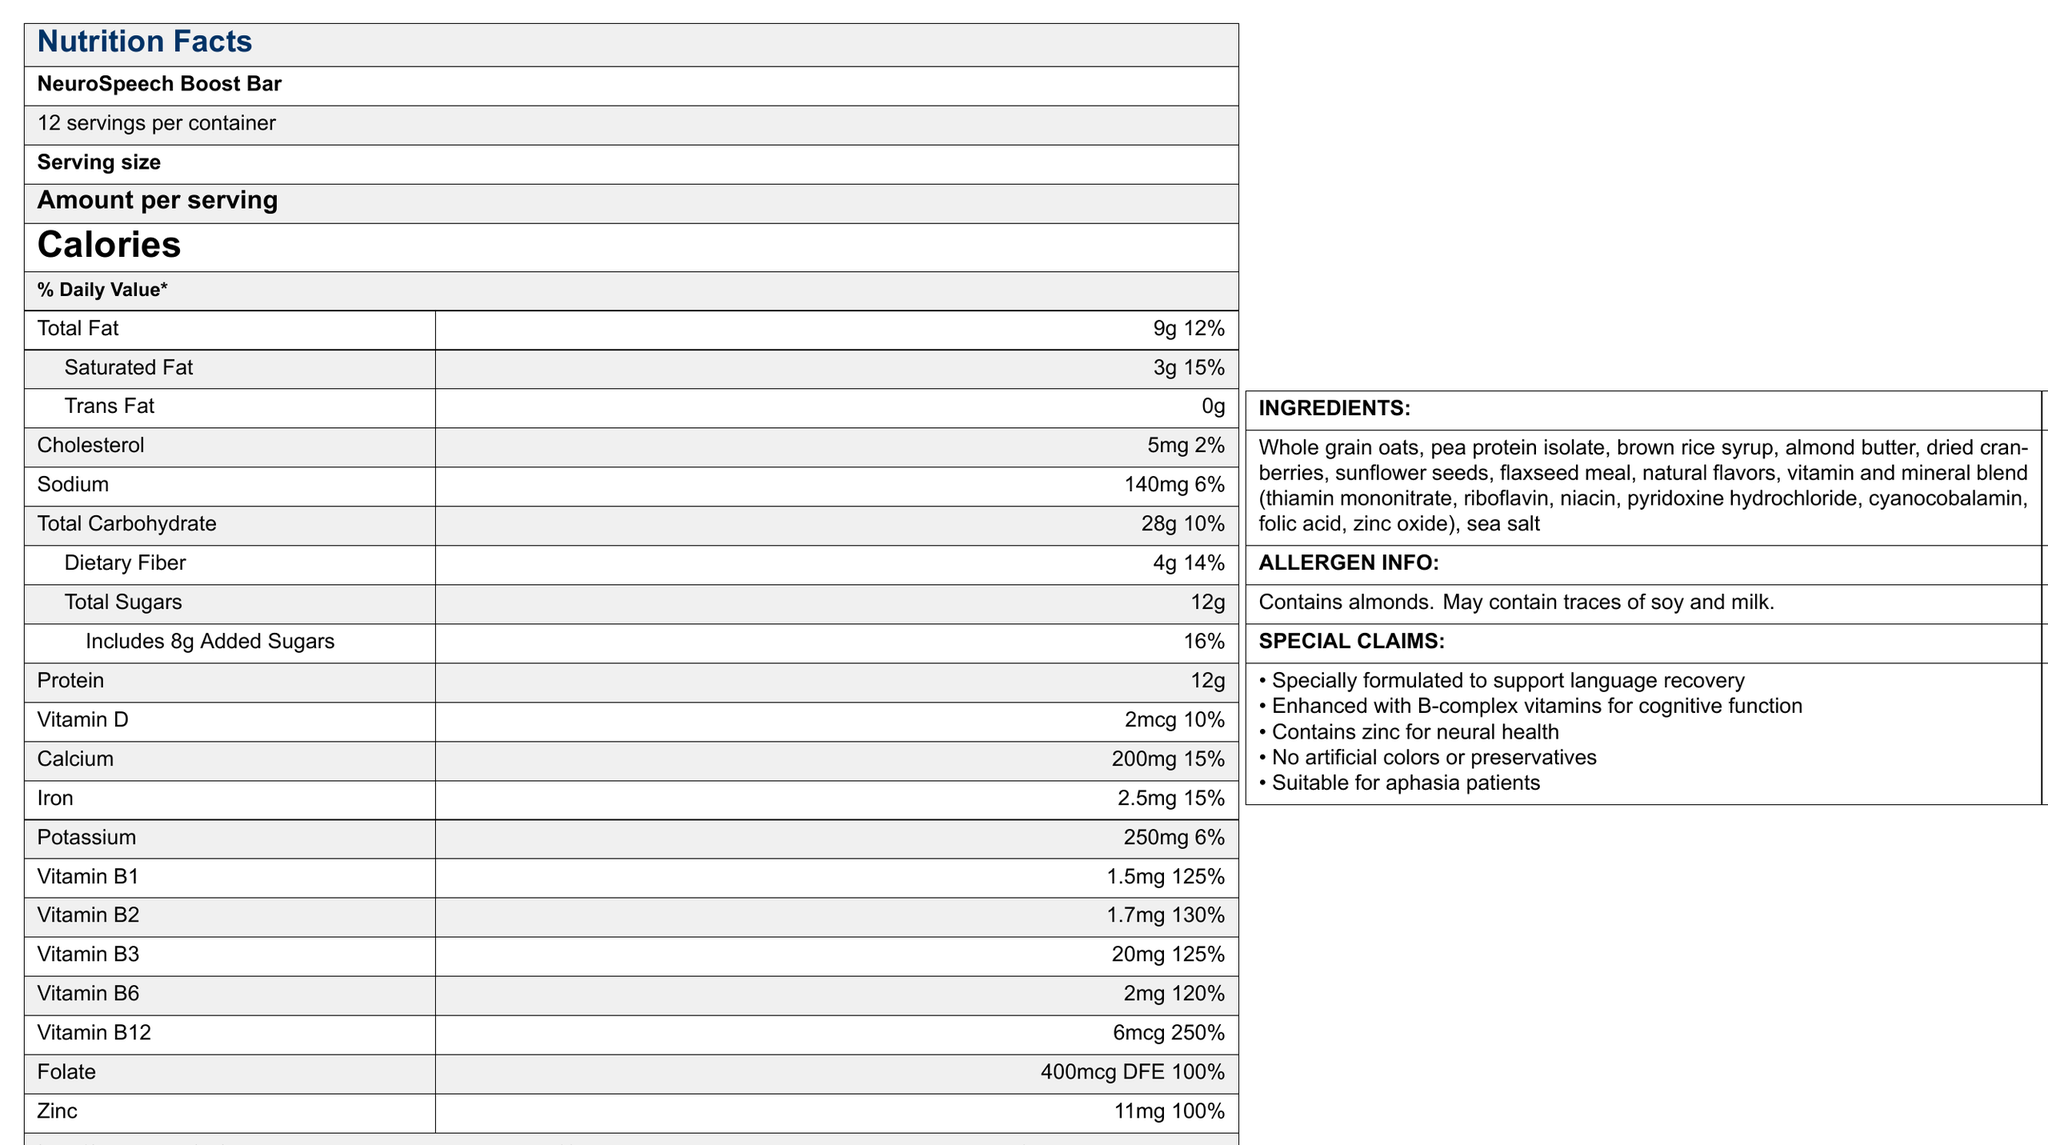what is the serving size? The document mentions "Serving size" as "1 bar (60g)".
Answer: 1 bar (60g) how many calories are in one serving? The document states that there are 230 calories per serving.
Answer: 230 what is the total fat content per serving? Under "Total Fat," the document specifies 9g.
Answer: 9g name two ingredients in the NeuroSpeech Boost Bar The ingredients list includes whole grain oats and pea protein isolate, along with other components.
Answer: Whole grain oats, pea protein isolate how much protein does one serving contain? The document mentions that one serving contains 12g of protein.
Answer: 12g does the bar contain any artificial colors or preservatives? According to the special claims, the bar contains "No artificial colors or preservatives."
Answer: No what allergies should be taken into consideration when consuming this bar? The allergen info specifies that it contains almonds and may contain traces of soy and milk.
Answer: almonds, traces of soy, and milk how much zinc is in one serving? The document lists zinc content as 11mg per serving.
Answer: 11mg which vitamin has the highest % daily value in this bar? A. Vitamin B1 B. Vitamin B2 C. Vitamin B6 D. Vitamin B12 The document shows Vitamin B12 with a % daily value of 250%, the highest among the listed vitamins.
Answer: D what nutrient contributes to 16% of the daily value in the bar? A. Total Fat B. Added Sugars C. Cholesterol D. Sodium Added Sugars contribute 16% of the daily value, as indicated in the document.
Answer: B is the NeuroSpeech Boost Bar suitable for aphasia patients? One of the special claims states that it is suitable for aphasia patients.
Answer: Yes what is the main purpose of the NeuroSpeech Boost Bar? The special claims highlight that the bar is specially formulated to support language recovery and enhance cognitive function.
Answer: To support language recovery and enhance cognitive function what roles do B-complex vitamins and zinc play according to the document? The special claims state that the bar is enhanced with B-complex vitamins for cognitive function and contains zinc for neural health.
Answer: B-complex vitamins support cognitive function; zinc supports neural health describe the main idea of the NeuroSpeech Boost Bar's nutrition facts label The label focuses on the nutritional composition of the NeuroSpeech Boost Bar, highlighting its benefits for language recovery and cognitive function, emphasizing its key ingredients and nutritional values, and ensuring it's suitable for aphasia patients.
Answer: The NeuroSpeech Boost Bar is a meal replacement bar designed to support language recovery. It has 230 calories per bar and contains key nutrients including B-complex vitamins and zinc. The bar provides 12g of protein per serving and has no artificial colors or preservatives. how much cholesterol is present per serving? The document lists the cholesterol content as 5mg per serving.
Answer: 5mg what is the % daily value of Vitamin D in the bar? According to the nutrition facts, Vitamin D contributes 10% of the daily value.
Answer: 10% how many servings per container are there? The document states that there are 12 servings per container.
Answer: 12 what is not mentioned in the document? A. Vitamin E content B. Total Fat content C. Protein content D. Sodium content The document does not mention the Vitamin E content.
Answer: A 